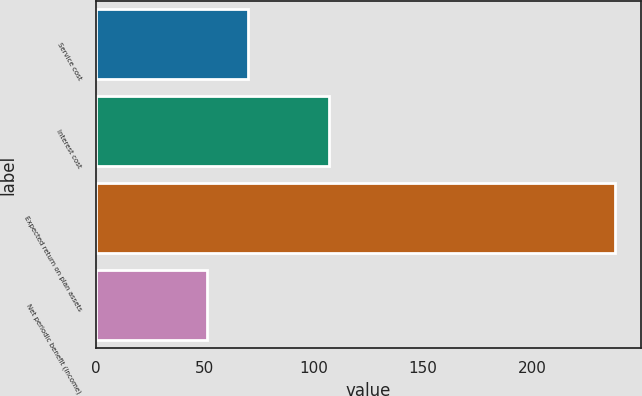Convert chart to OTSL. <chart><loc_0><loc_0><loc_500><loc_500><bar_chart><fcel>Service cost<fcel>Interest cost<fcel>Expected return on plan assets<fcel>Net periodic benefit (income)<nl><fcel>69.7<fcel>107.1<fcel>238<fcel>51<nl></chart> 